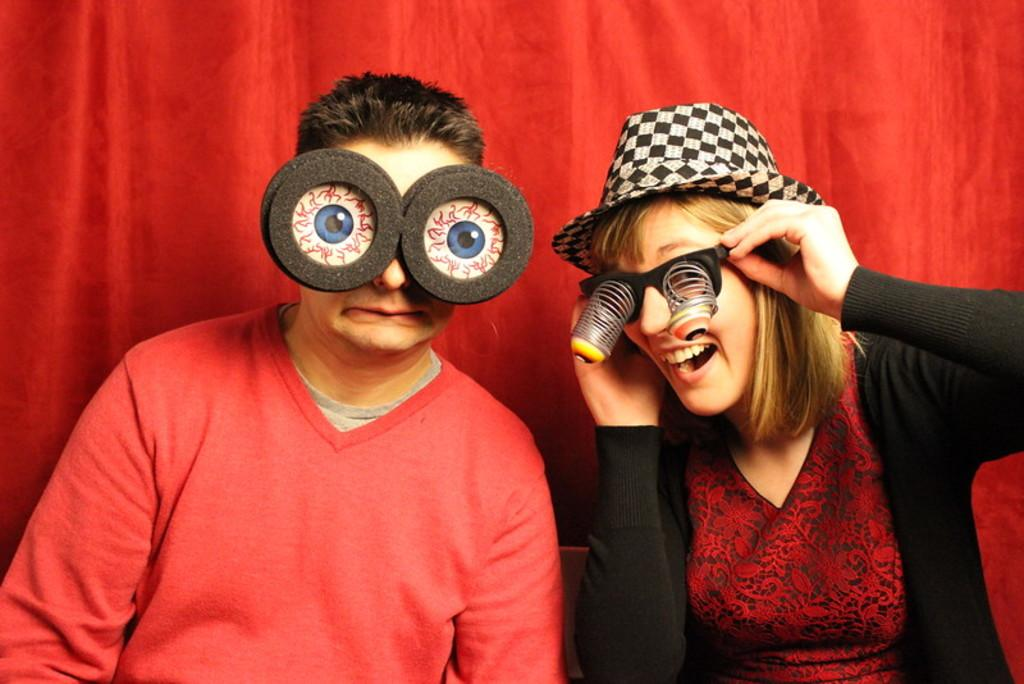How many people are present in the image? There are two people in the image, a man and a woman. What is the woman wearing on her head? The woman is wearing a cap on her head. What can be seen in the background of the image? There is a curtain visible in the image. What are the man and woman wearing on their faces? Both the man and woman are wearing eyewear. What time of day is it in the image, and how many hens are present? The time of day cannot be determined from the image, and there are no hens present. What is the woman's elbow doing in the image? There is no specific mention of the woman's elbow in the provided facts, so it cannot be determined what it is doing. 